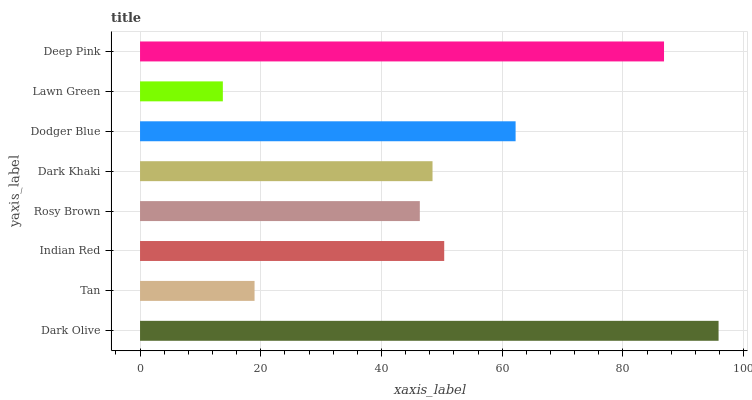Is Lawn Green the minimum?
Answer yes or no. Yes. Is Dark Olive the maximum?
Answer yes or no. Yes. Is Tan the minimum?
Answer yes or no. No. Is Tan the maximum?
Answer yes or no. No. Is Dark Olive greater than Tan?
Answer yes or no. Yes. Is Tan less than Dark Olive?
Answer yes or no. Yes. Is Tan greater than Dark Olive?
Answer yes or no. No. Is Dark Olive less than Tan?
Answer yes or no. No. Is Indian Red the high median?
Answer yes or no. Yes. Is Dark Khaki the low median?
Answer yes or no. Yes. Is Lawn Green the high median?
Answer yes or no. No. Is Dark Olive the low median?
Answer yes or no. No. 